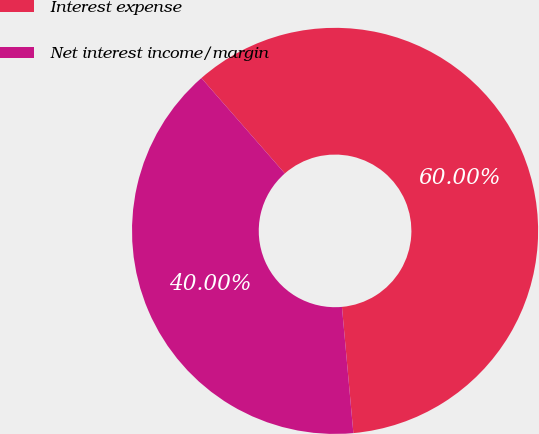Convert chart. <chart><loc_0><loc_0><loc_500><loc_500><pie_chart><fcel>Interest expense<fcel>Net interest income/margin<nl><fcel>60.0%<fcel>40.0%<nl></chart> 